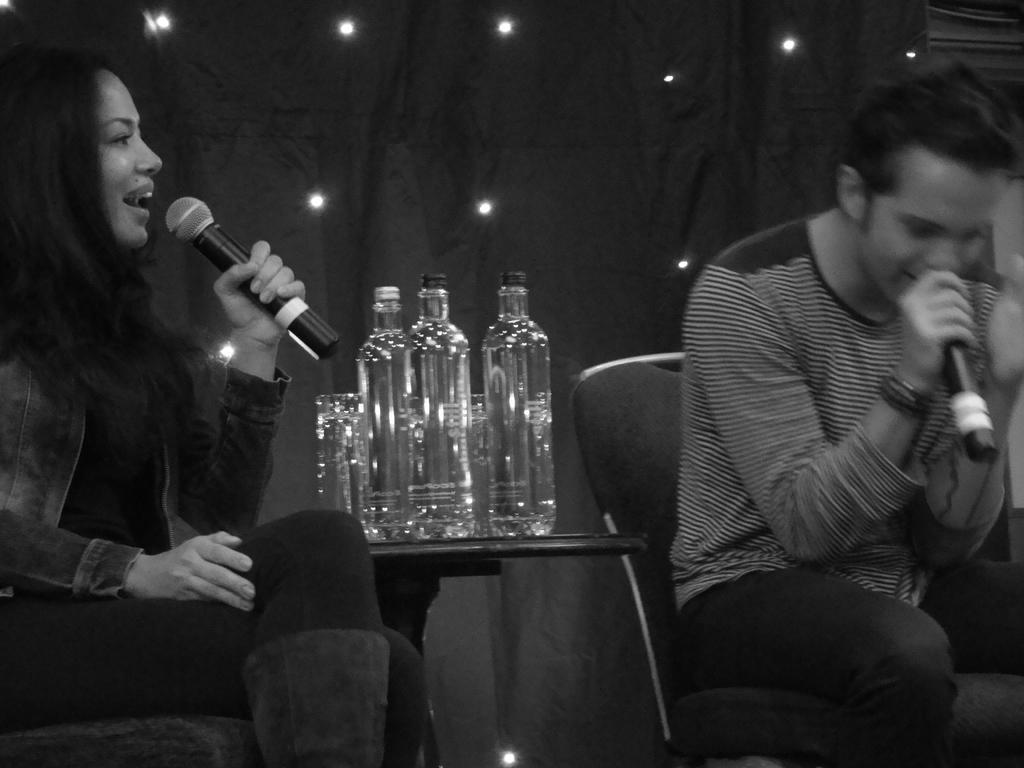Describe this image in one or two sentences. There is a woman and man with microphones sitting on chairs with table in between them with few bottles on it. 